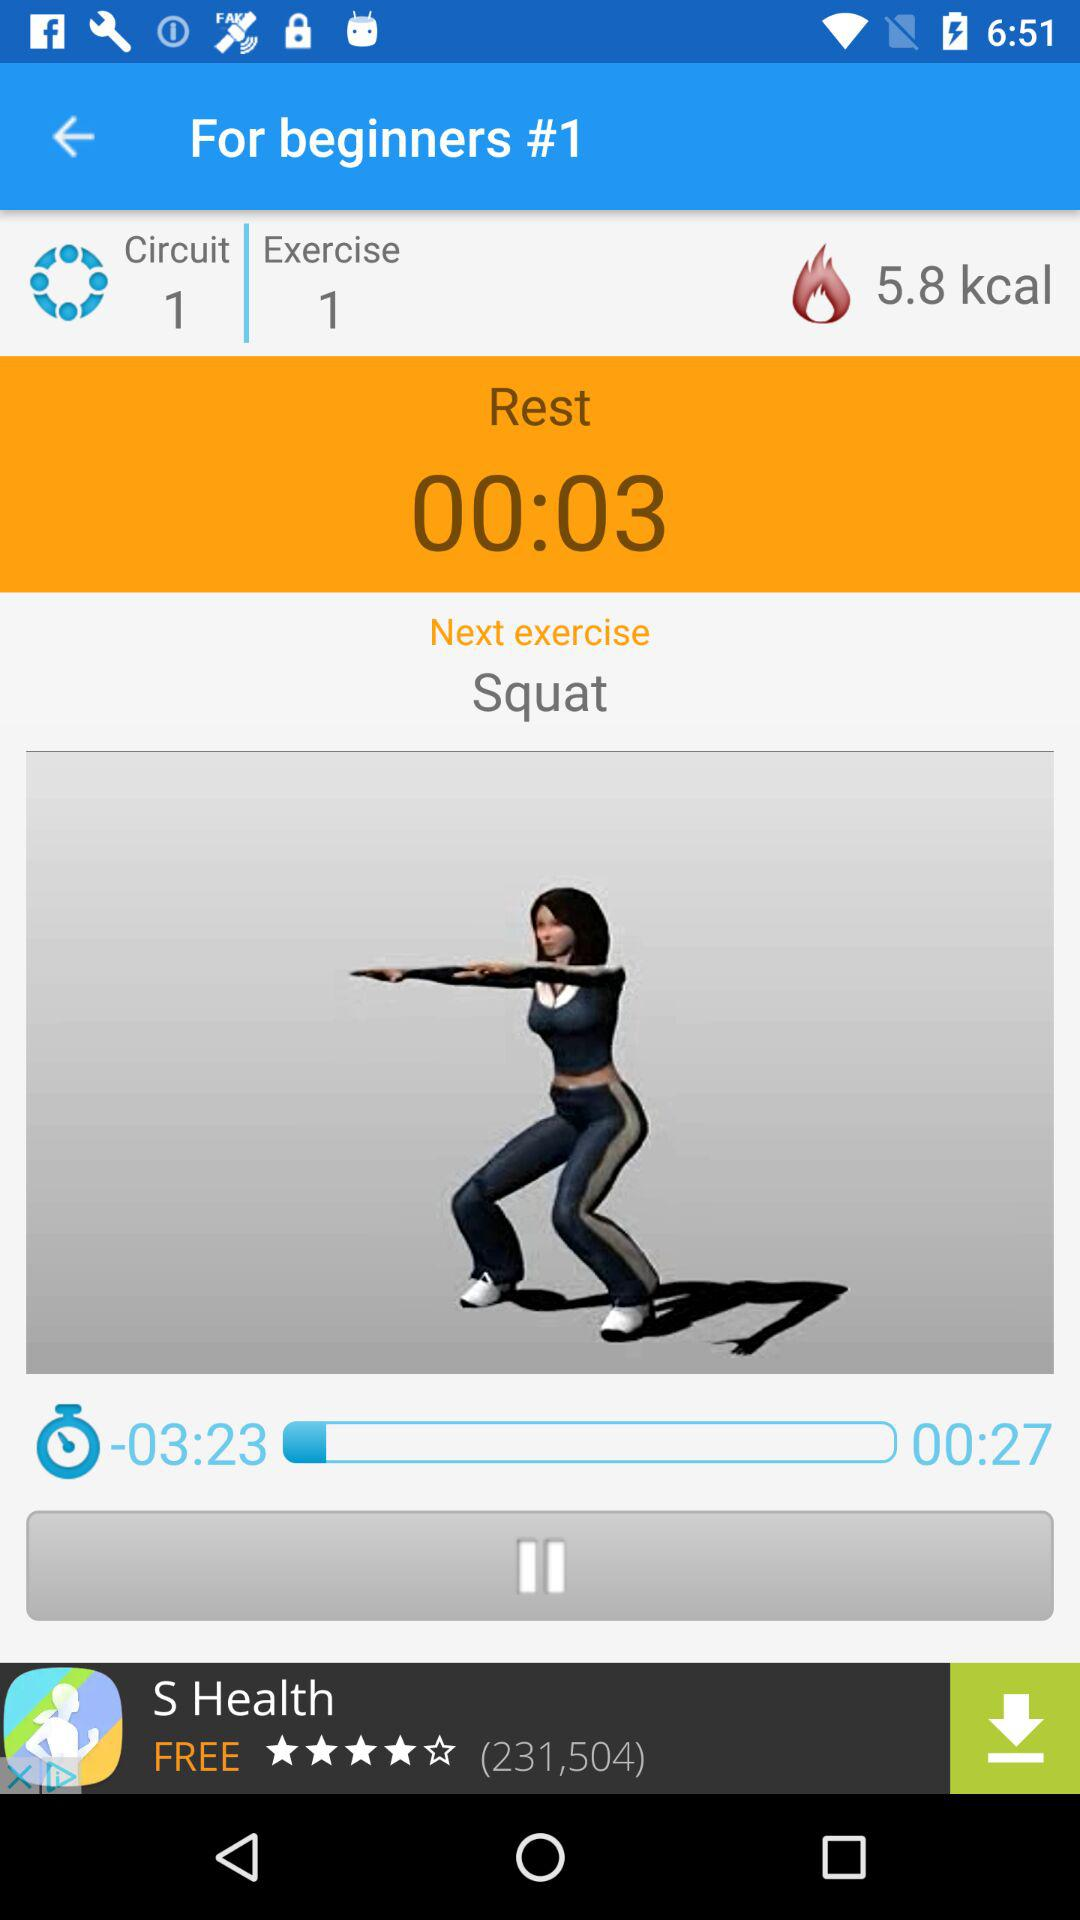How many calories are burned in exercise 1? There are 5.8 kilocalories burned in exercise 1. 